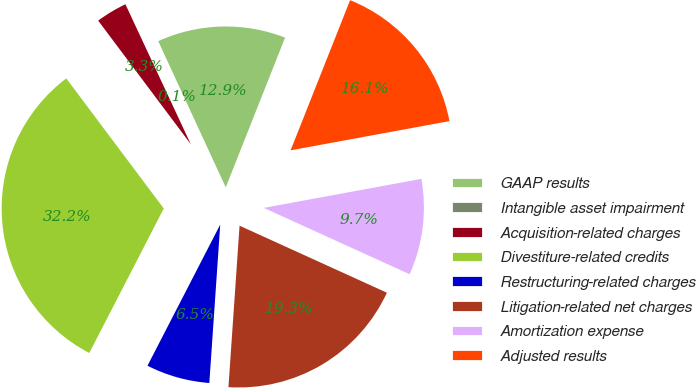Convert chart to OTSL. <chart><loc_0><loc_0><loc_500><loc_500><pie_chart><fcel>GAAP results<fcel>Intangible asset impairment<fcel>Acquisition-related charges<fcel>Divestiture-related credits<fcel>Restructuring-related charges<fcel>Litigation-related net charges<fcel>Amortization expense<fcel>Adjusted results<nl><fcel>12.89%<fcel>0.07%<fcel>3.28%<fcel>32.19%<fcel>6.48%<fcel>19.3%<fcel>9.69%<fcel>16.1%<nl></chart> 